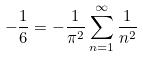<formula> <loc_0><loc_0><loc_500><loc_500>- \frac { 1 } { 6 } = - \frac { 1 } { \pi ^ { 2 } } \sum _ { n = 1 } ^ { \infty } \frac { 1 } { n ^ { 2 } }</formula> 